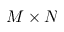Convert formula to latex. <formula><loc_0><loc_0><loc_500><loc_500>M \times N</formula> 